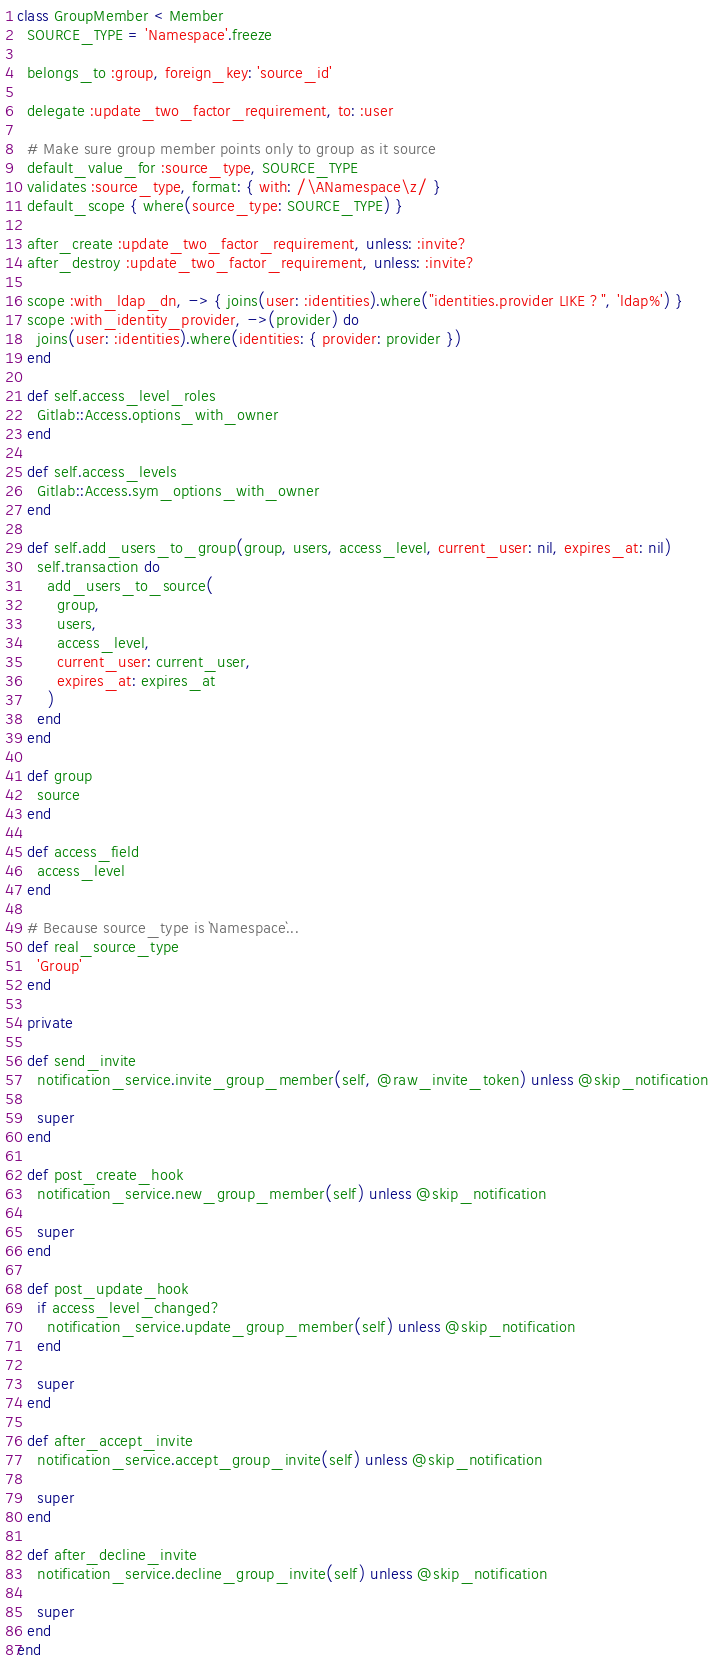Convert code to text. <code><loc_0><loc_0><loc_500><loc_500><_Ruby_>class GroupMember < Member
  SOURCE_TYPE = 'Namespace'.freeze

  belongs_to :group, foreign_key: 'source_id'

  delegate :update_two_factor_requirement, to: :user

  # Make sure group member points only to group as it source
  default_value_for :source_type, SOURCE_TYPE
  validates :source_type, format: { with: /\ANamespace\z/ }
  default_scope { where(source_type: SOURCE_TYPE) }

  after_create :update_two_factor_requirement, unless: :invite?
  after_destroy :update_two_factor_requirement, unless: :invite?

  scope :with_ldap_dn, -> { joins(user: :identities).where("identities.provider LIKE ?", 'ldap%') }
  scope :with_identity_provider, ->(provider) do
    joins(user: :identities).where(identities: { provider: provider })
  end

  def self.access_level_roles
    Gitlab::Access.options_with_owner
  end

  def self.access_levels
    Gitlab::Access.sym_options_with_owner
  end

  def self.add_users_to_group(group, users, access_level, current_user: nil, expires_at: nil)
    self.transaction do
      add_users_to_source(
        group,
        users,
        access_level,
        current_user: current_user,
        expires_at: expires_at
      )
    end
  end

  def group
    source
  end

  def access_field
    access_level
  end

  # Because source_type is `Namespace`...
  def real_source_type
    'Group'
  end

  private

  def send_invite
    notification_service.invite_group_member(self, @raw_invite_token) unless @skip_notification

    super
  end

  def post_create_hook
    notification_service.new_group_member(self) unless @skip_notification

    super
  end

  def post_update_hook
    if access_level_changed?
      notification_service.update_group_member(self) unless @skip_notification
    end

    super
  end

  def after_accept_invite
    notification_service.accept_group_invite(self) unless @skip_notification

    super
  end

  def after_decline_invite
    notification_service.decline_group_invite(self) unless @skip_notification

    super
  end
end
</code> 